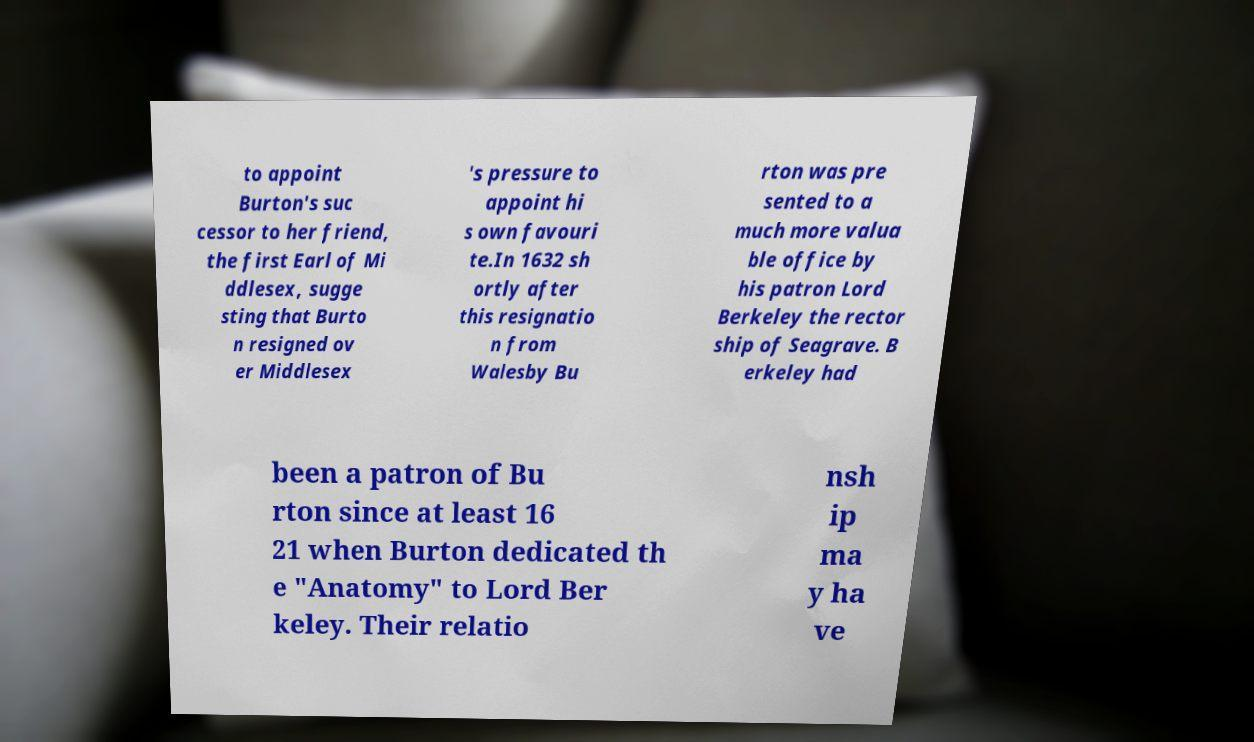Please read and relay the text visible in this image. What does it say? to appoint Burton's suc cessor to her friend, the first Earl of Mi ddlesex, sugge sting that Burto n resigned ov er Middlesex 's pressure to appoint hi s own favouri te.In 1632 sh ortly after this resignatio n from Walesby Bu rton was pre sented to a much more valua ble office by his patron Lord Berkeley the rector ship of Seagrave. B erkeley had been a patron of Bu rton since at least 16 21 when Burton dedicated th e "Anatomy" to Lord Ber keley. Their relatio nsh ip ma y ha ve 